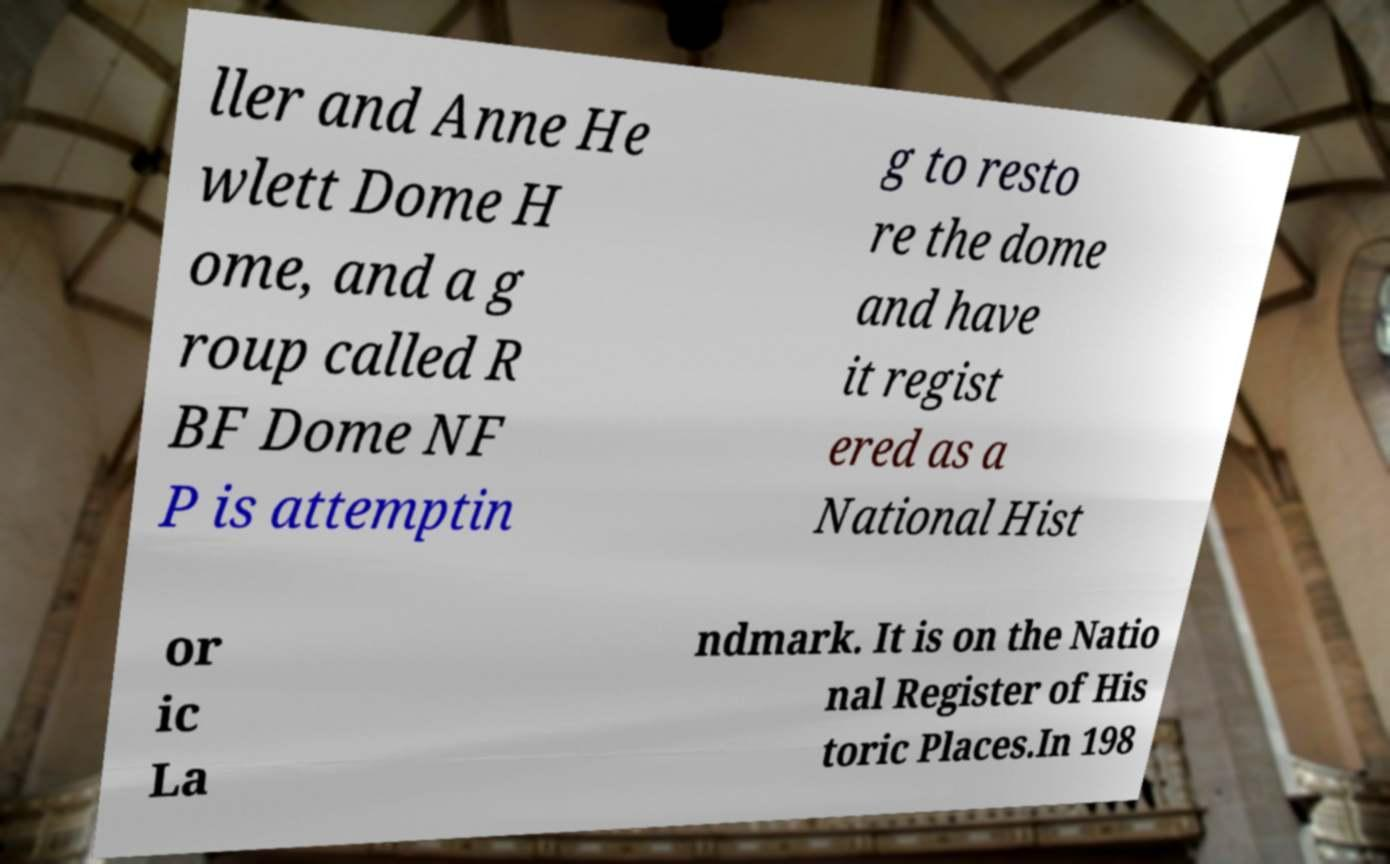What messages or text are displayed in this image? I need them in a readable, typed format. ller and Anne He wlett Dome H ome, and a g roup called R BF Dome NF P is attemptin g to resto re the dome and have it regist ered as a National Hist or ic La ndmark. It is on the Natio nal Register of His toric Places.In 198 